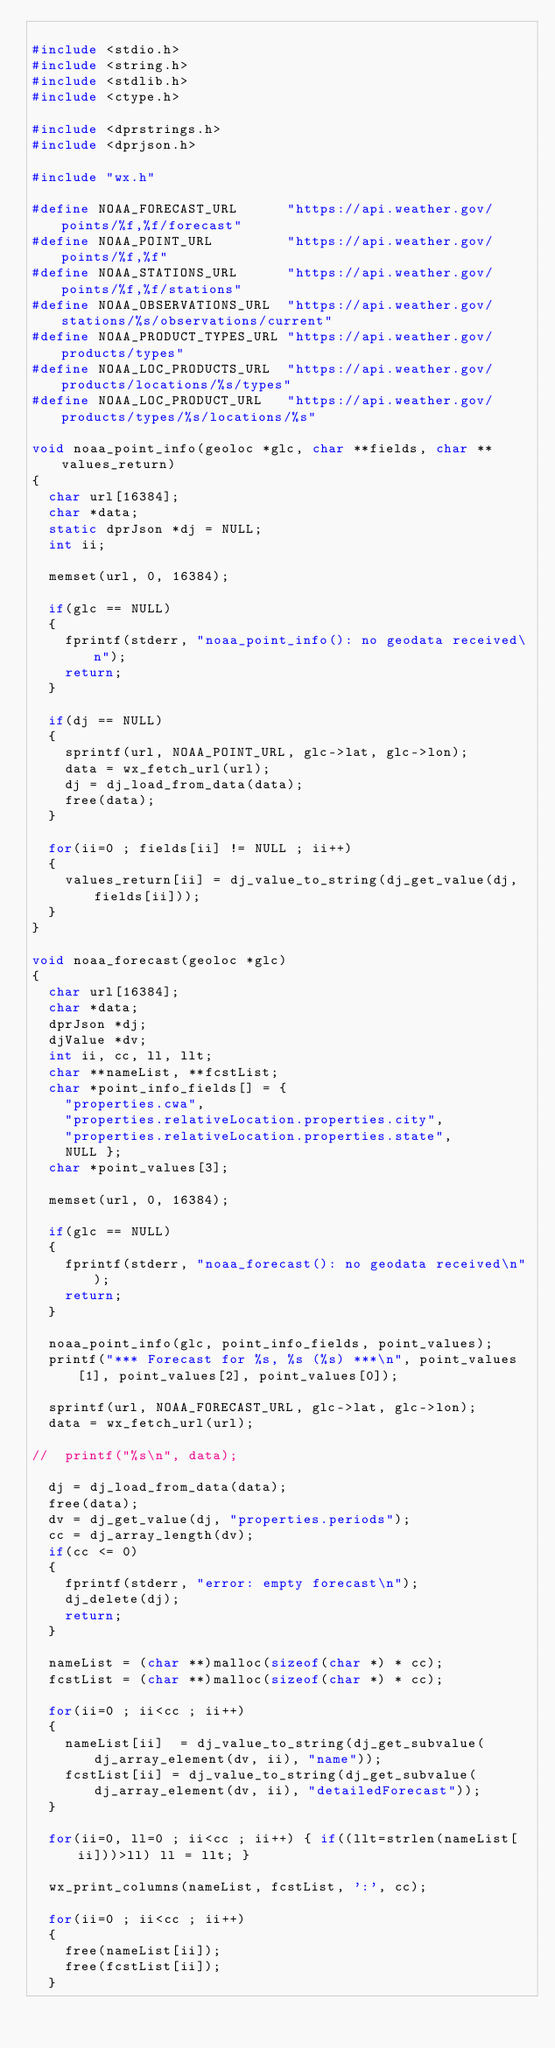<code> <loc_0><loc_0><loc_500><loc_500><_C_>
#include <stdio.h>
#include <string.h>
#include <stdlib.h>
#include <ctype.h>

#include <dprstrings.h>
#include <dprjson.h>

#include "wx.h"

#define NOAA_FORECAST_URL      "https://api.weather.gov/points/%f,%f/forecast"
#define NOAA_POINT_URL         "https://api.weather.gov/points/%f,%f"
#define NOAA_STATIONS_URL      "https://api.weather.gov/points/%f,%f/stations"
#define NOAA_OBSERVATIONS_URL  "https://api.weather.gov/stations/%s/observations/current"
#define NOAA_PRODUCT_TYPES_URL "https://api.weather.gov/products/types"
#define NOAA_LOC_PRODUCTS_URL  "https://api.weather.gov/products/locations/%s/types"
#define NOAA_LOC_PRODUCT_URL   "https://api.weather.gov/products/types/%s/locations/%s"

void noaa_point_info(geoloc *glc, char **fields, char **values_return)
{
  char url[16384];
  char *data;
  static dprJson *dj = NULL;
  int ii;

  memset(url, 0, 16384);

  if(glc == NULL)
  {
    fprintf(stderr, "noaa_point_info(): no geodata received\n");
    return;
  }

  if(dj == NULL)
  {
    sprintf(url, NOAA_POINT_URL, glc->lat, glc->lon);
    data = wx_fetch_url(url);
    dj = dj_load_from_data(data);
    free(data);
  }

  for(ii=0 ; fields[ii] != NULL ; ii++)
  {
    values_return[ii] = dj_value_to_string(dj_get_value(dj, fields[ii]));
  }
}

void noaa_forecast(geoloc *glc)
{
  char url[16384];
  char *data;
  dprJson *dj;
  djValue *dv;
  int ii, cc, ll, llt;
  char **nameList, **fcstList;
  char *point_info_fields[] = {
    "properties.cwa",
    "properties.relativeLocation.properties.city",
    "properties.relativeLocation.properties.state",
    NULL };
  char *point_values[3];

  memset(url, 0, 16384);

  if(glc == NULL)
  {
    fprintf(stderr, "noaa_forecast(): no geodata received\n");
    return;
  }

  noaa_point_info(glc, point_info_fields, point_values);
  printf("*** Forecast for %s, %s (%s) ***\n", point_values[1], point_values[2], point_values[0]);

  sprintf(url, NOAA_FORECAST_URL, glc->lat, glc->lon);
  data = wx_fetch_url(url);
  
//  printf("%s\n", data);

  dj = dj_load_from_data(data);
  free(data);
  dv = dj_get_value(dj, "properties.periods");
  cc = dj_array_length(dv);
  if(cc <= 0)
  {
    fprintf(stderr, "error: empty forecast\n");
    dj_delete(dj);
    return;
  }

  nameList = (char **)malloc(sizeof(char *) * cc);
  fcstList = (char **)malloc(sizeof(char *) * cc);

  for(ii=0 ; ii<cc ; ii++)
  {
    nameList[ii]  = dj_value_to_string(dj_get_subvalue(dj_array_element(dv, ii), "name"));
    fcstList[ii] = dj_value_to_string(dj_get_subvalue(dj_array_element(dv, ii), "detailedForecast"));
  }

  for(ii=0, ll=0 ; ii<cc ; ii++) { if((llt=strlen(nameList[ii]))>ll) ll = llt; }

  wx_print_columns(nameList, fcstList, ':', cc);

  for(ii=0 ; ii<cc ; ii++)
  {
    free(nameList[ii]);
    free(fcstList[ii]);
  }</code> 